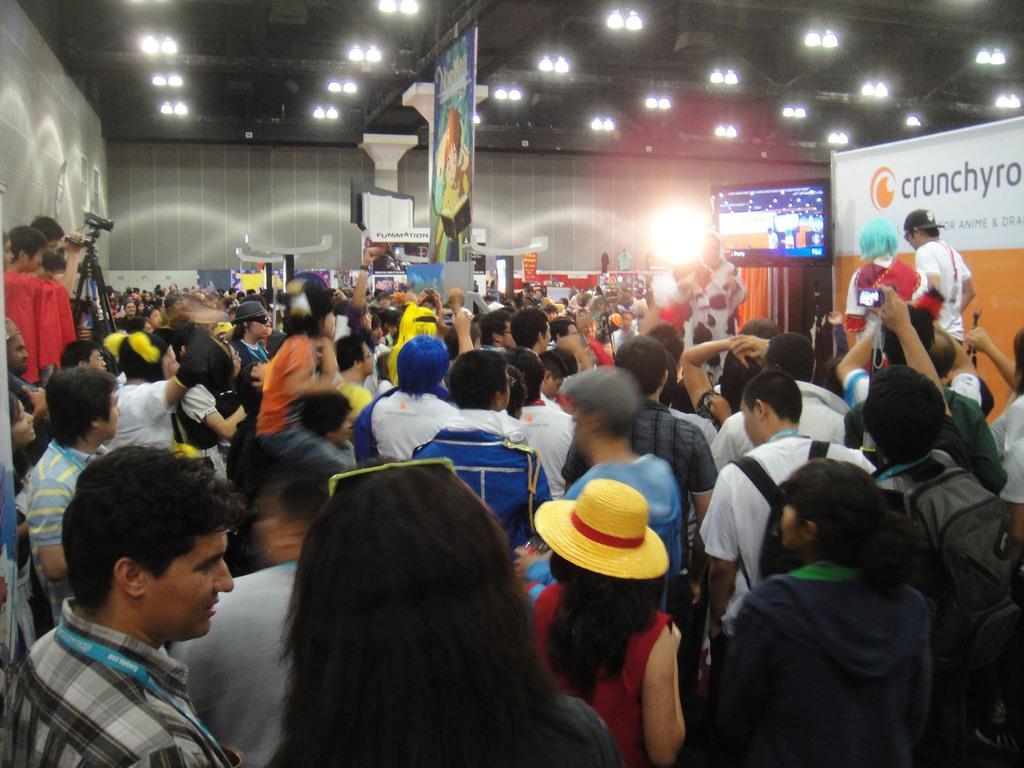Describe this image in one or two sentences. In this image I can see the group of people and few people are holding something. I can see few boards, banners, screen, lights and few objects. I can see the person is holding the camera. 